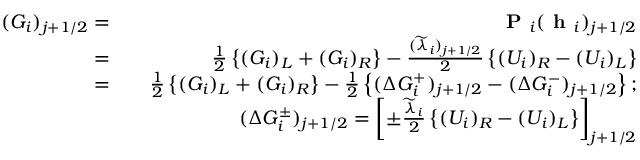Convert formula to latex. <formula><loc_0><loc_0><loc_500><loc_500>\begin{array} { r l r } { ( G _ { i } ) _ { j + 1 / 2 } = } & { P _ { i } ( h _ { i } ) _ { j + 1 / 2 } } \\ { = } & { \frac { 1 } { 2 } \left \{ ( G _ { i } ) _ { L } + ( G _ { i } ) _ { R } \right \} - \frac { ( \widetilde { \lambda } _ { i } ) _ { j + 1 / 2 } } { 2 } \left \{ ( U _ { i } ) _ { R } - ( U _ { i } ) _ { L } \right \} } \\ { = } & { \frac { 1 } { 2 } \left \{ ( G _ { i } ) _ { L } + ( G _ { i } ) _ { R } \right \} - \frac { 1 } { 2 } \left \{ ( \Delta G _ { i } ^ { + } ) _ { j + 1 / 2 } - ( \Delta G _ { i } ^ { - } ) _ { j + 1 / 2 } \right \} ; } \\ & { ( \Delta G _ { i } ^ { \pm } ) _ { j + 1 / 2 } = \left [ { \pm } \frac { \widetilde { \lambda } _ { i } } { 2 } \left \{ ( U _ { i } ) _ { R } - ( U _ { i } ) _ { L } \right \} \right ] _ { j + 1 / 2 } } \end{array}</formula> 